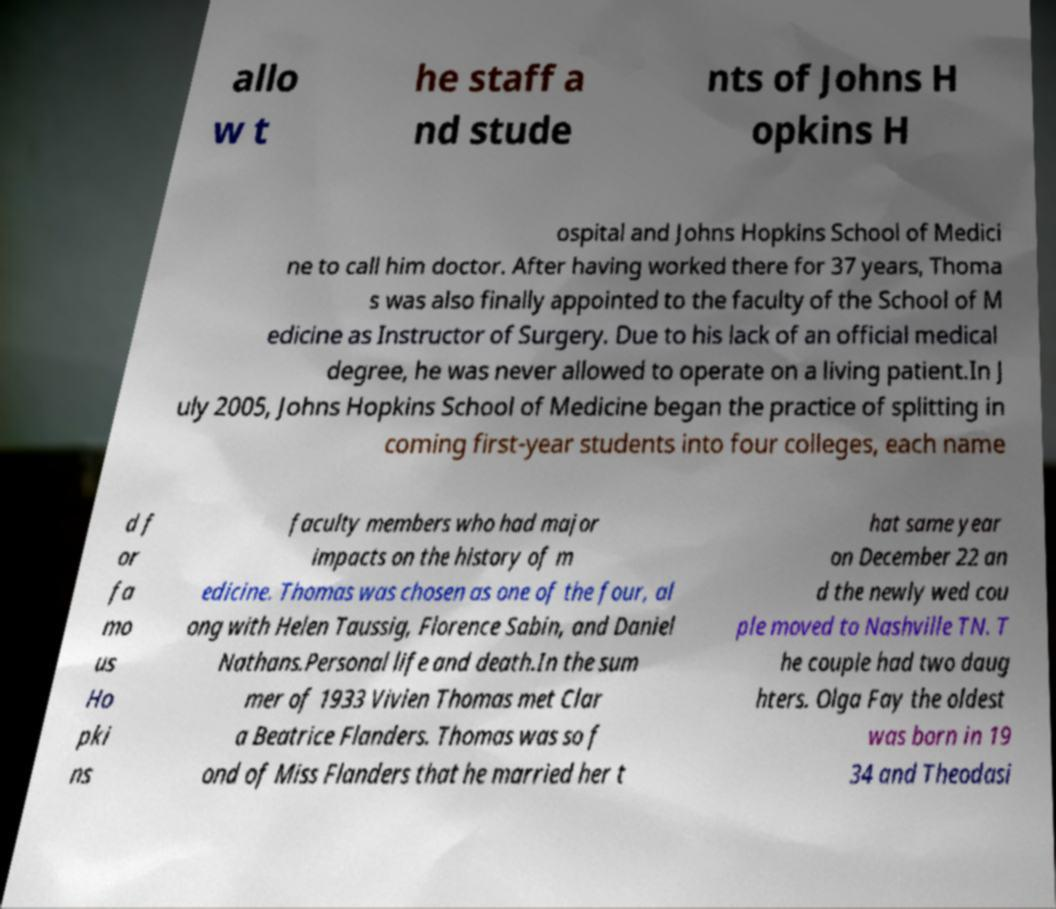What messages or text are displayed in this image? I need them in a readable, typed format. allo w t he staff a nd stude nts of Johns H opkins H ospital and Johns Hopkins School of Medici ne to call him doctor. After having worked there for 37 years, Thoma s was also finally appointed to the faculty of the School of M edicine as Instructor of Surgery. Due to his lack of an official medical degree, he was never allowed to operate on a living patient.In J uly 2005, Johns Hopkins School of Medicine began the practice of splitting in coming first-year students into four colleges, each name d f or fa mo us Ho pki ns faculty members who had major impacts on the history of m edicine. Thomas was chosen as one of the four, al ong with Helen Taussig, Florence Sabin, and Daniel Nathans.Personal life and death.In the sum mer of 1933 Vivien Thomas met Clar a Beatrice Flanders. Thomas was so f ond of Miss Flanders that he married her t hat same year on December 22 an d the newly wed cou ple moved to Nashville TN. T he couple had two daug hters. Olga Fay the oldest was born in 19 34 and Theodasi 